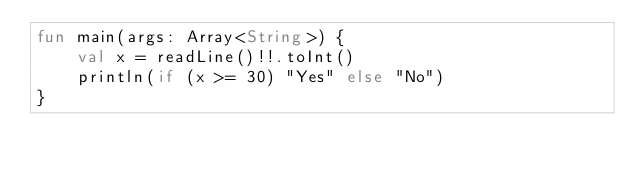<code> <loc_0><loc_0><loc_500><loc_500><_Kotlin_>fun main(args: Array<String>) {
    val x = readLine()!!.toInt()
    println(if (x >= 30) "Yes" else "No")
}
</code> 